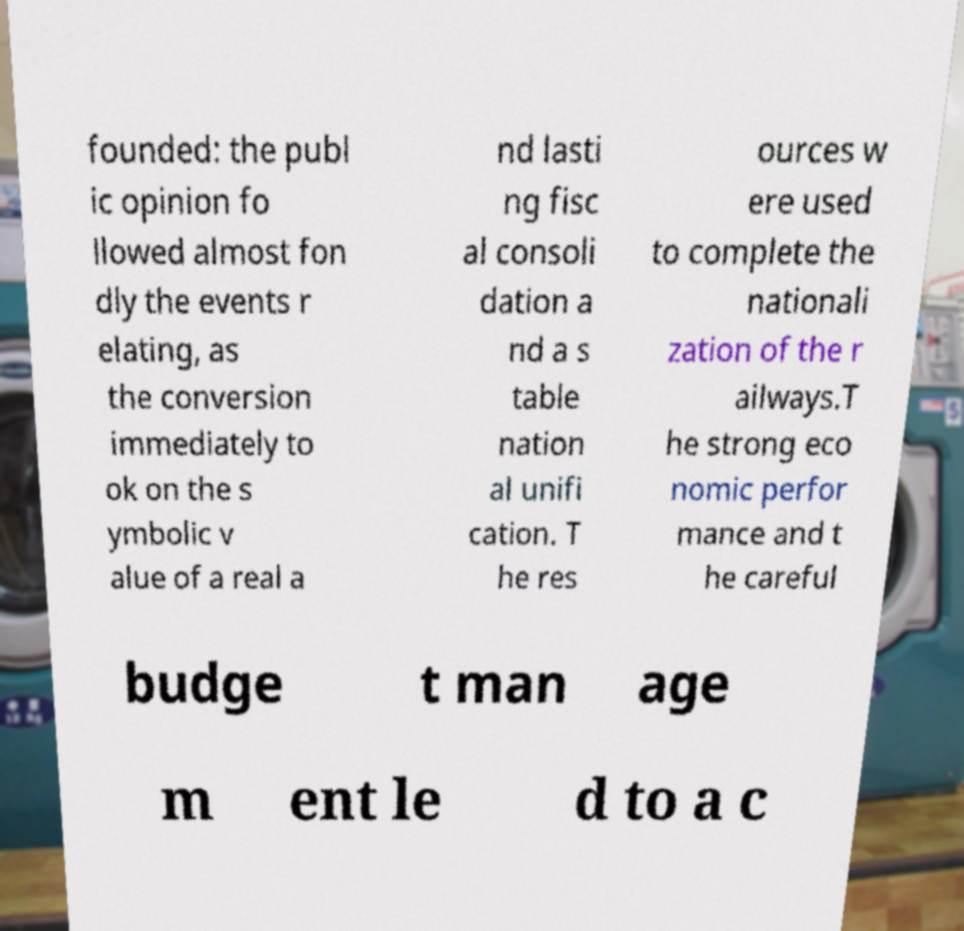I need the written content from this picture converted into text. Can you do that? founded: the publ ic opinion fo llowed almost fon dly the events r elating, as the conversion immediately to ok on the s ymbolic v alue of a real a nd lasti ng fisc al consoli dation a nd a s table nation al unifi cation. T he res ources w ere used to complete the nationali zation of the r ailways.T he strong eco nomic perfor mance and t he careful budge t man age m ent le d to a c 